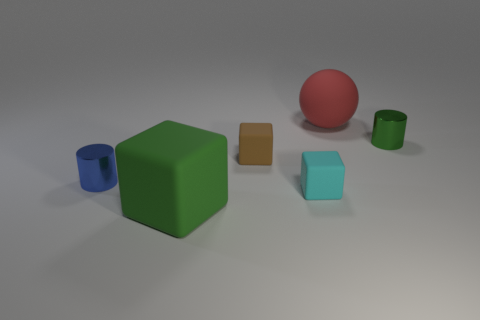How do the different textures of the objects contribute to the overall composition? Each object in the scene has a distinct texture that contributes to the composition by creating visual variety. The large red sphere has a smooth, matte texture which contrasts with the shiny finish of the blue and green cylinders. The green cube has a slight roughness, which differs from the smoothness of the brown rectangle, and this interplay of textures adds depth and interest to the scene. 